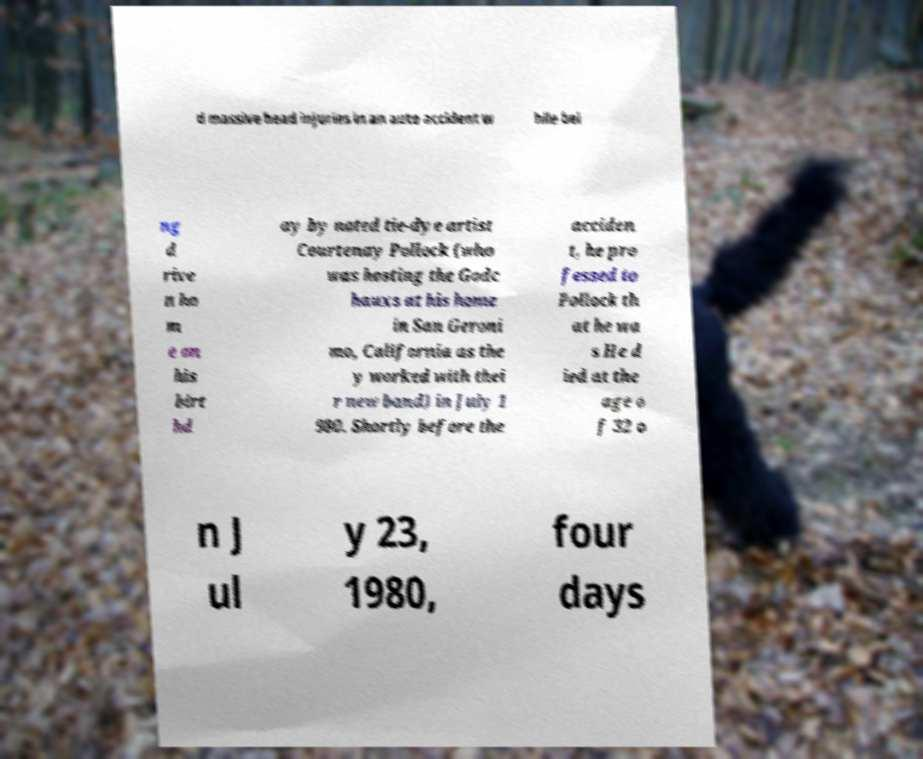Can you read and provide the text displayed in the image?This photo seems to have some interesting text. Can you extract and type it out for me? d massive head injuries in an auto accident w hile bei ng d rive n ho m e on his birt hd ay by noted tie-dye artist Courtenay Pollock (who was hosting the Godc hauxs at his home in San Geroni mo, California as the y worked with thei r new band) in July 1 980. Shortly before the acciden t, he pro fessed to Pollock th at he wa s He d ied at the age o f 32 o n J ul y 23, 1980, four days 